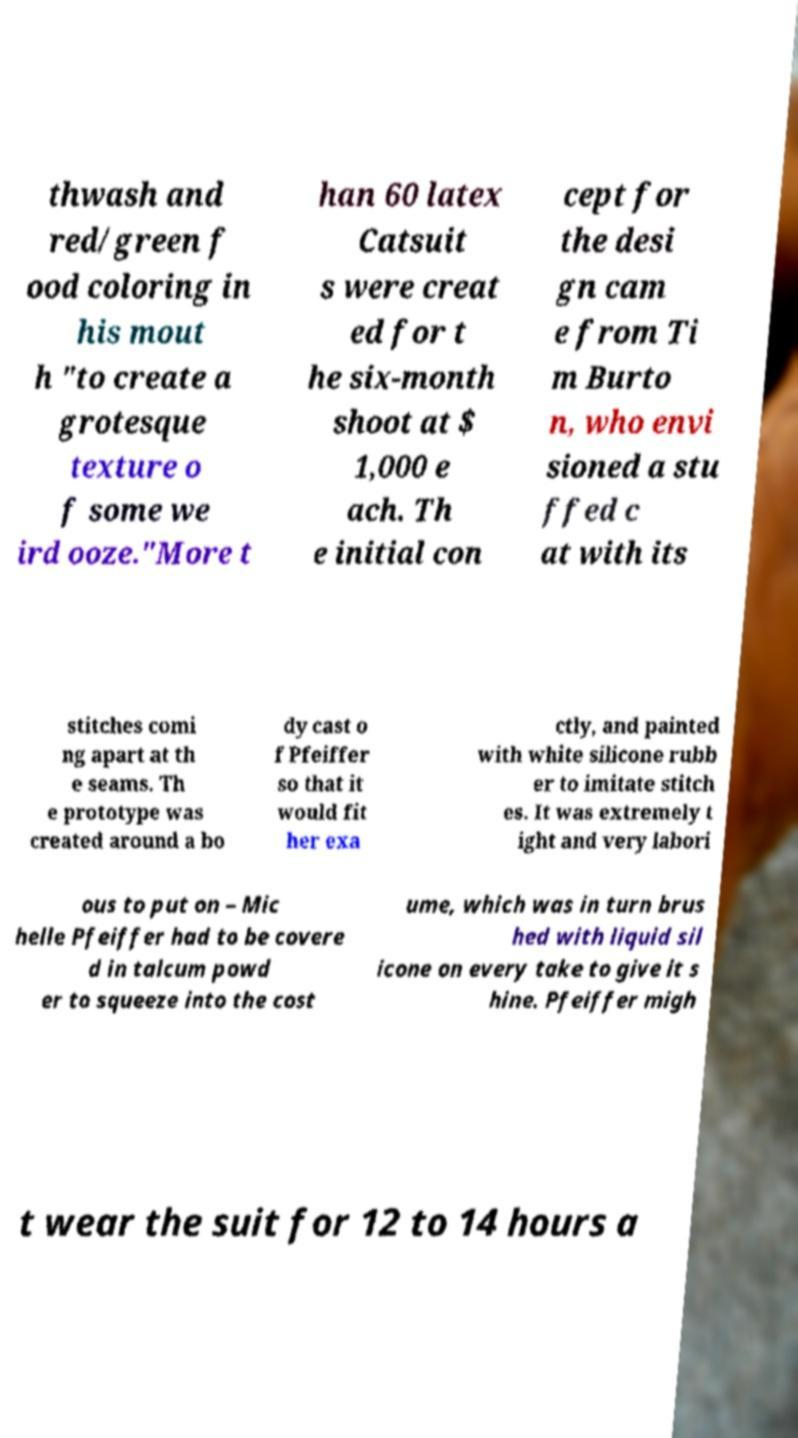Can you accurately transcribe the text from the provided image for me? thwash and red/green f ood coloring in his mout h "to create a grotesque texture o f some we ird ooze."More t han 60 latex Catsuit s were creat ed for t he six-month shoot at $ 1,000 e ach. Th e initial con cept for the desi gn cam e from Ti m Burto n, who envi sioned a stu ffed c at with its stitches comi ng apart at th e seams. Th e prototype was created around a bo dy cast o f Pfeiffer so that it would fit her exa ctly, and painted with white silicone rubb er to imitate stitch es. It was extremely t ight and very labori ous to put on – Mic helle Pfeiffer had to be covere d in talcum powd er to squeeze into the cost ume, which was in turn brus hed with liquid sil icone on every take to give it s hine. Pfeiffer migh t wear the suit for 12 to 14 hours a 